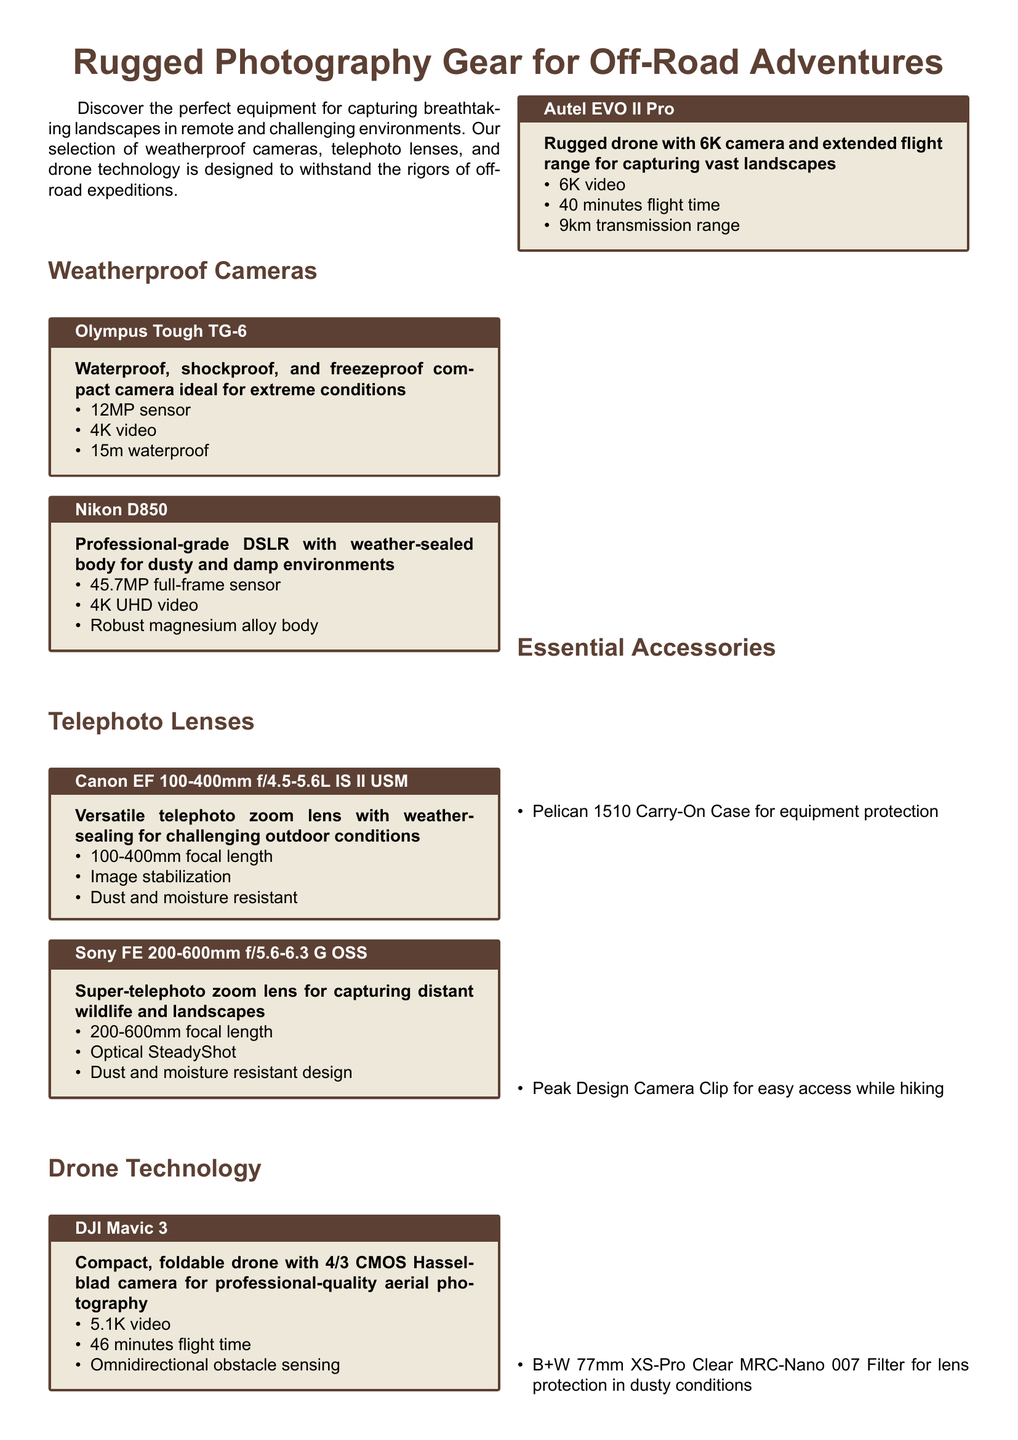What is the maximum video resolution of the Olympus Tough TG-6? The document states that the Olympus Tough TG-6 has a 4K video capability.
Answer: 4K How many megapixels does the Nikon D850 camera have? The Nikon D850 features a 45.7MP full-frame sensor according to the document.
Answer: 45.7MP What is the flight time of the DJI Mavic 3 drone? The document mentions that the DJI Mavic 3 has a flight time of 46 minutes.
Answer: 46 minutes Which telephoto lens has a focal length of 200-600mm? The Sony FE 200-600mm f/5.6-6.3 G OSS is the lens with this specified focal length in the document.
Answer: Sony FE 200-600mm f/5.6-6.3 G OSS What type of protection does the Pelican 1510 Carry-On Case offer? The document indicates that it is for equipment protection.
Answer: Equipment protection How many items are listed under Essential Accessories? There are three items mentioned under Essential Accessories in the document.
Answer: Three What is the weight limit for the Canon EF 100-400mm f/4.5-5.6L IS II USM lens? The document does not specify a weight limit for the lens; it describes weather-sealing instead. Therefore, this is a reasoning question.
Answer: Not specified What does the Omnidirectional obstacle sensing feature pertain to? This feature is related to the DJI Mavic 3 drone for safety during flight.
Answer: DJI Mavic 3 Which lens has image stabilization technology? The Canon EF 100-400mm f/4.5-5.6L IS II USM includes image stabilization technology, as mentioned.
Answer: Canon EF 100-400mm f/4.5-5.6L IS II USM 